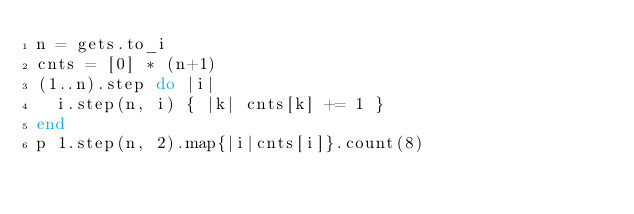Convert code to text. <code><loc_0><loc_0><loc_500><loc_500><_Ruby_>n = gets.to_i
cnts = [0] * (n+1)
(1..n).step do |i|
  i.step(n, i) { |k| cnts[k] += 1 }
end
p 1.step(n, 2).map{|i|cnts[i]}.count(8)</code> 